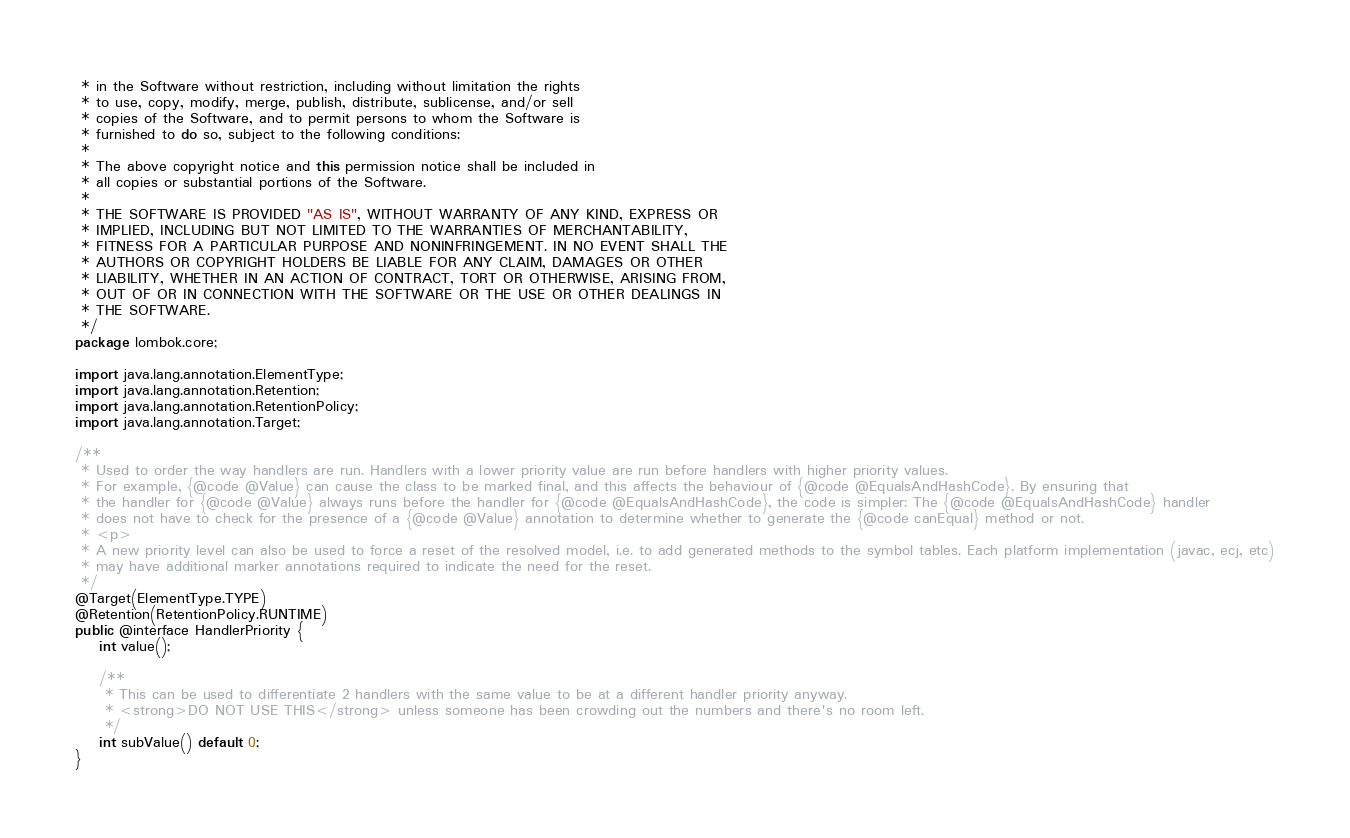Convert code to text. <code><loc_0><loc_0><loc_500><loc_500><_Java_> * in the Software without restriction, including without limitation the rights
 * to use, copy, modify, merge, publish, distribute, sublicense, and/or sell
 * copies of the Software, and to permit persons to whom the Software is
 * furnished to do so, subject to the following conditions:
 * 
 * The above copyright notice and this permission notice shall be included in
 * all copies or substantial portions of the Software.
 * 
 * THE SOFTWARE IS PROVIDED "AS IS", WITHOUT WARRANTY OF ANY KIND, EXPRESS OR
 * IMPLIED, INCLUDING BUT NOT LIMITED TO THE WARRANTIES OF MERCHANTABILITY,
 * FITNESS FOR A PARTICULAR PURPOSE AND NONINFRINGEMENT. IN NO EVENT SHALL THE
 * AUTHORS OR COPYRIGHT HOLDERS BE LIABLE FOR ANY CLAIM, DAMAGES OR OTHER
 * LIABILITY, WHETHER IN AN ACTION OF CONTRACT, TORT OR OTHERWISE, ARISING FROM,
 * OUT OF OR IN CONNECTION WITH THE SOFTWARE OR THE USE OR OTHER DEALINGS IN
 * THE SOFTWARE.
 */
package lombok.core;

import java.lang.annotation.ElementType;
import java.lang.annotation.Retention;
import java.lang.annotation.RetentionPolicy;
import java.lang.annotation.Target;

/**
 * Used to order the way handlers are run. Handlers with a lower priority value are run before handlers with higher priority values.
 * For example, {@code @Value} can cause the class to be marked final, and this affects the behaviour of {@code @EqualsAndHashCode}. By ensuring that
 * the handler for {@code @Value} always runs before the handler for {@code @EqualsAndHashCode}, the code is simpler: The {@code @EqualsAndHashCode} handler
 * does not have to check for the presence of a {@code @Value} annotation to determine whether to generate the {@code canEqual} method or not.
 * <p>
 * A new priority level can also be used to force a reset of the resolved model, i.e. to add generated methods to the symbol tables. Each platform implementation (javac, ecj, etc)
 * may have additional marker annotations required to indicate the need for the reset.
 */
@Target(ElementType.TYPE)
@Retention(RetentionPolicy.RUNTIME)
public @interface HandlerPriority {
	int value();
	
	/**
	 * This can be used to differentiate 2 handlers with the same value to be at a different handler priority anyway.
	 * <strong>DO NOT USE THIS</strong> unless someone has been crowding out the numbers and there's no room left.
	 */
	int subValue() default 0;
}
</code> 